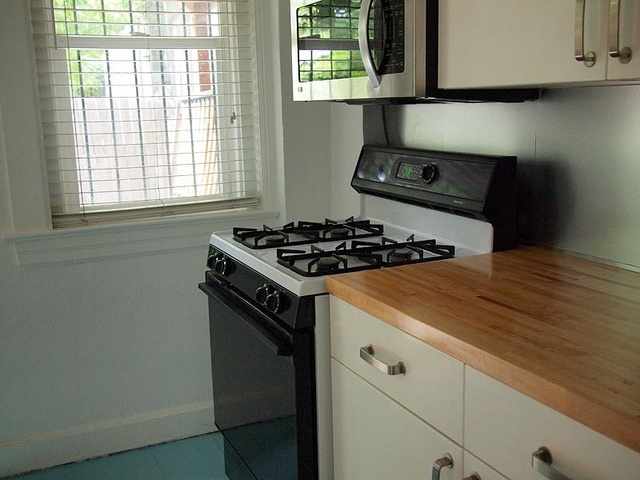Describe the objects in this image and their specific colors. I can see oven in gray, black, and darkgray tones and microwave in gray, black, ivory, and darkgray tones in this image. 